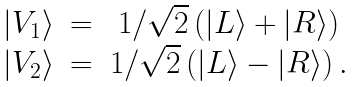<formula> <loc_0><loc_0><loc_500><loc_500>\begin{array} { c c c } | V _ { 1 } \rangle & = & 1 / \sqrt { 2 } \left ( | L \rangle + | R \rangle \right ) \\ | V _ { 2 } \rangle & = & 1 / \sqrt { 2 } \left ( | L \rangle - | R \rangle \right ) . \\ \end{array}</formula> 